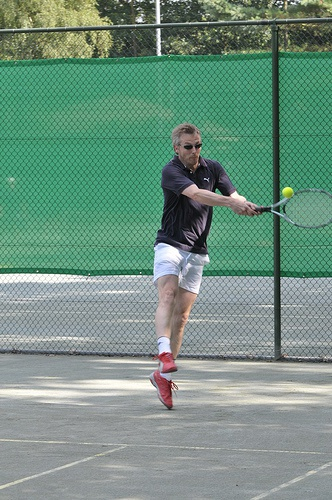Describe the objects in this image and their specific colors. I can see people in olive, black, gray, and darkgray tones, tennis racket in olive, teal, and darkgray tones, and sports ball in olive, yellow, and khaki tones in this image. 